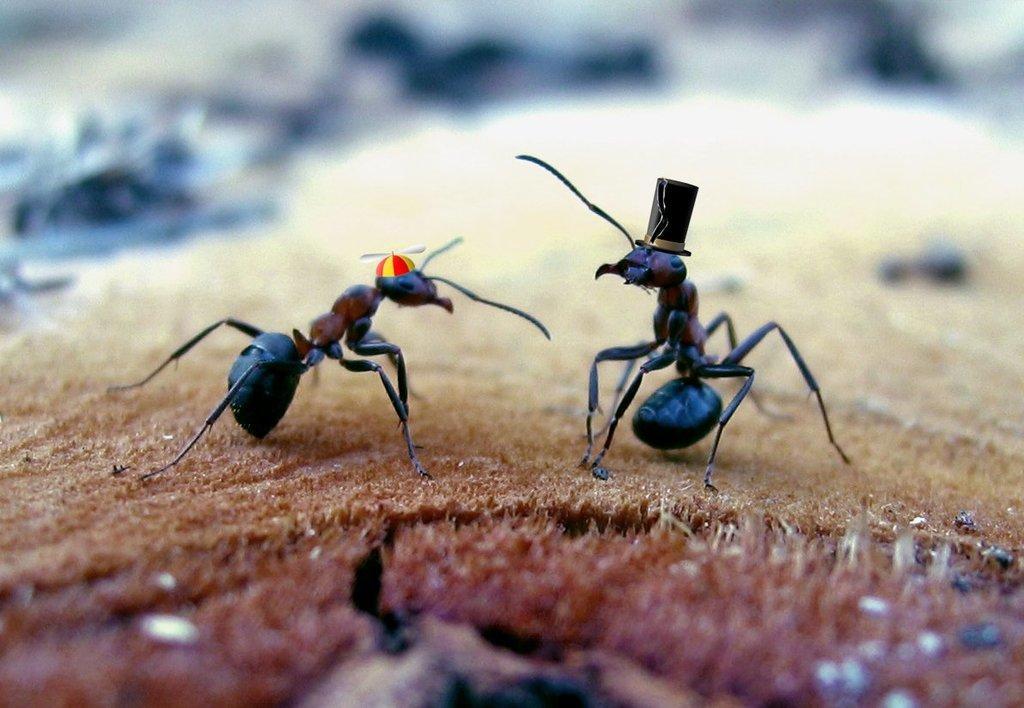Please provide a concise description of this image. In this image we can see the ants on the surface. We can also see the caps. 